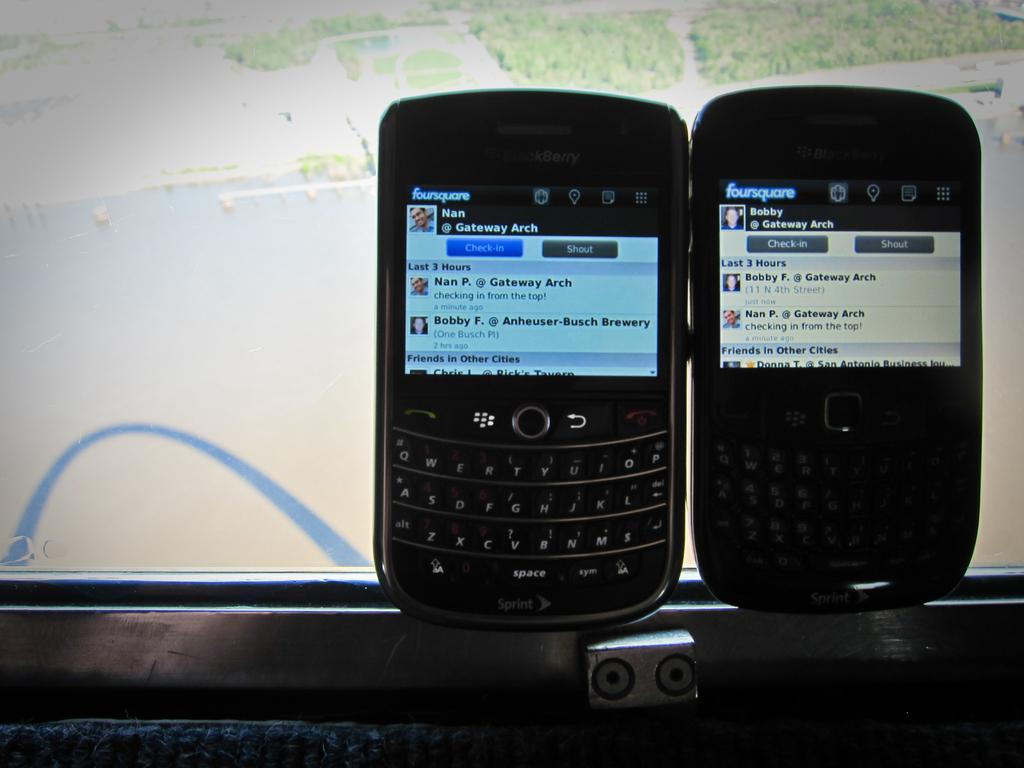<image>
Render a clear and concise summary of the photo. a foursquare phone that has a green background 